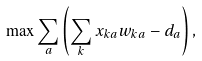<formula> <loc_0><loc_0><loc_500><loc_500>\max \sum _ { a } \left ( \sum _ { k } x _ { k a } w _ { k a } - d _ { a } \right ) ,</formula> 